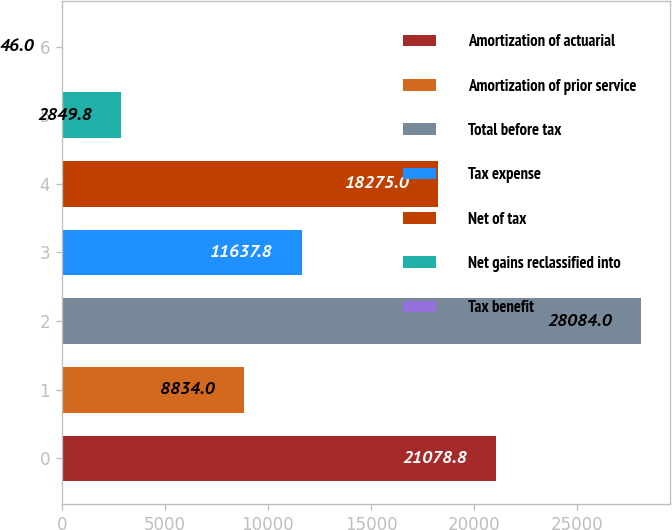Convert chart. <chart><loc_0><loc_0><loc_500><loc_500><bar_chart><fcel>Amortization of actuarial<fcel>Amortization of prior service<fcel>Total before tax<fcel>Tax expense<fcel>Net of tax<fcel>Net gains reclassified into<fcel>Tax benefit<nl><fcel>21078.8<fcel>8834<fcel>28084<fcel>11637.8<fcel>18275<fcel>2849.8<fcel>46<nl></chart> 